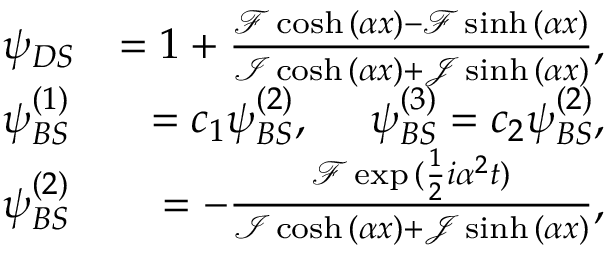<formula> <loc_0><loc_0><loc_500><loc_500>\begin{array} { r l r } & { \psi _ { D S } } & { = 1 + \frac { \mathcal { F } \cosh { ( \alpha x ) } - \mathcal { F } \sinh { ( \alpha x ) } } { \mathcal { I } \cosh { ( \alpha x ) } + \mathcal { J } \sinh { ( \alpha x ) } } , } \\ & { \psi _ { B S } ^ { ( 1 ) } } & { = c _ { 1 } \psi _ { B S } ^ { ( 2 ) } , \psi _ { B S } ^ { ( 3 ) } = c _ { 2 } \psi _ { B S } ^ { ( 2 ) } , } \\ & { \psi _ { B S } ^ { ( 2 ) } } & { = - \frac { \mathcal { F } \exp { ( \frac { 1 } { 2 } i \alpha ^ { 2 } t ) } } { \mathcal { I } \cosh { ( \alpha x ) } + \mathcal { J } \sinh { ( \alpha x ) } } , } \end{array}</formula> 